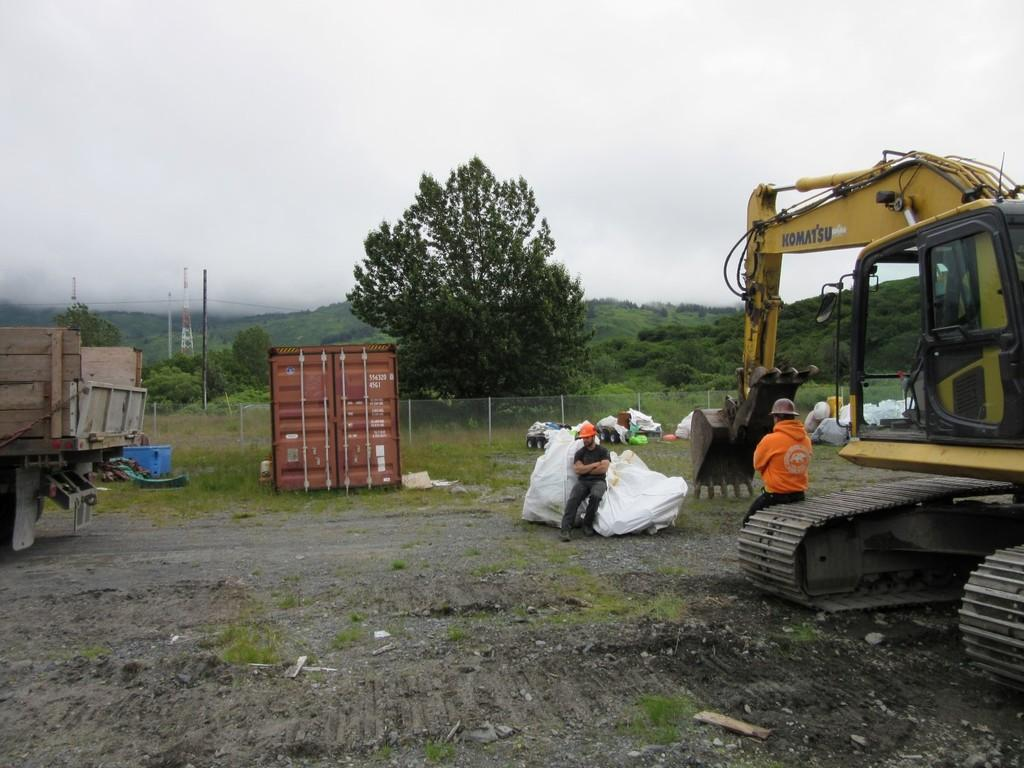<image>
Share a concise interpretation of the image provided. Two men stand around a work area next to a Komatsu digger. 